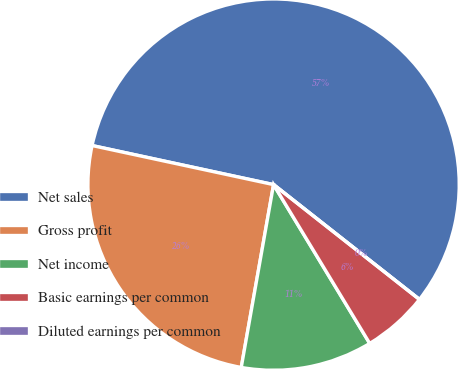Convert chart. <chart><loc_0><loc_0><loc_500><loc_500><pie_chart><fcel>Net sales<fcel>Gross profit<fcel>Net income<fcel>Basic earnings per common<fcel>Diluted earnings per common<nl><fcel>57.24%<fcel>25.59%<fcel>11.45%<fcel>5.72%<fcel>0.0%<nl></chart> 